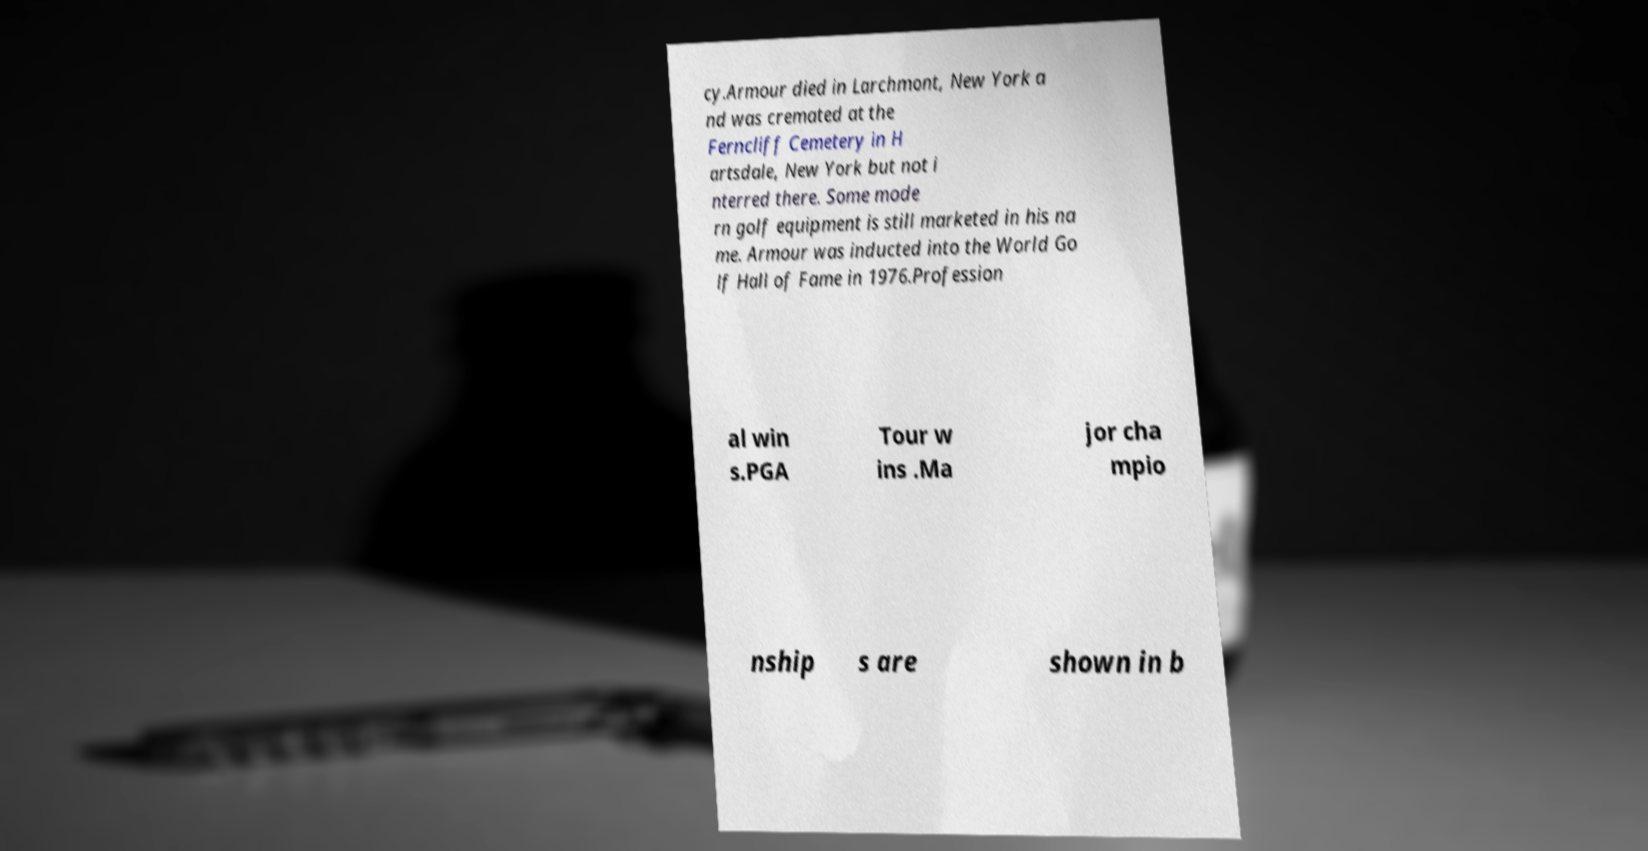Can you read and provide the text displayed in the image?This photo seems to have some interesting text. Can you extract and type it out for me? cy.Armour died in Larchmont, New York a nd was cremated at the Ferncliff Cemetery in H artsdale, New York but not i nterred there. Some mode rn golf equipment is still marketed in his na me. Armour was inducted into the World Go lf Hall of Fame in 1976.Profession al win s.PGA Tour w ins .Ma jor cha mpio nship s are shown in b 